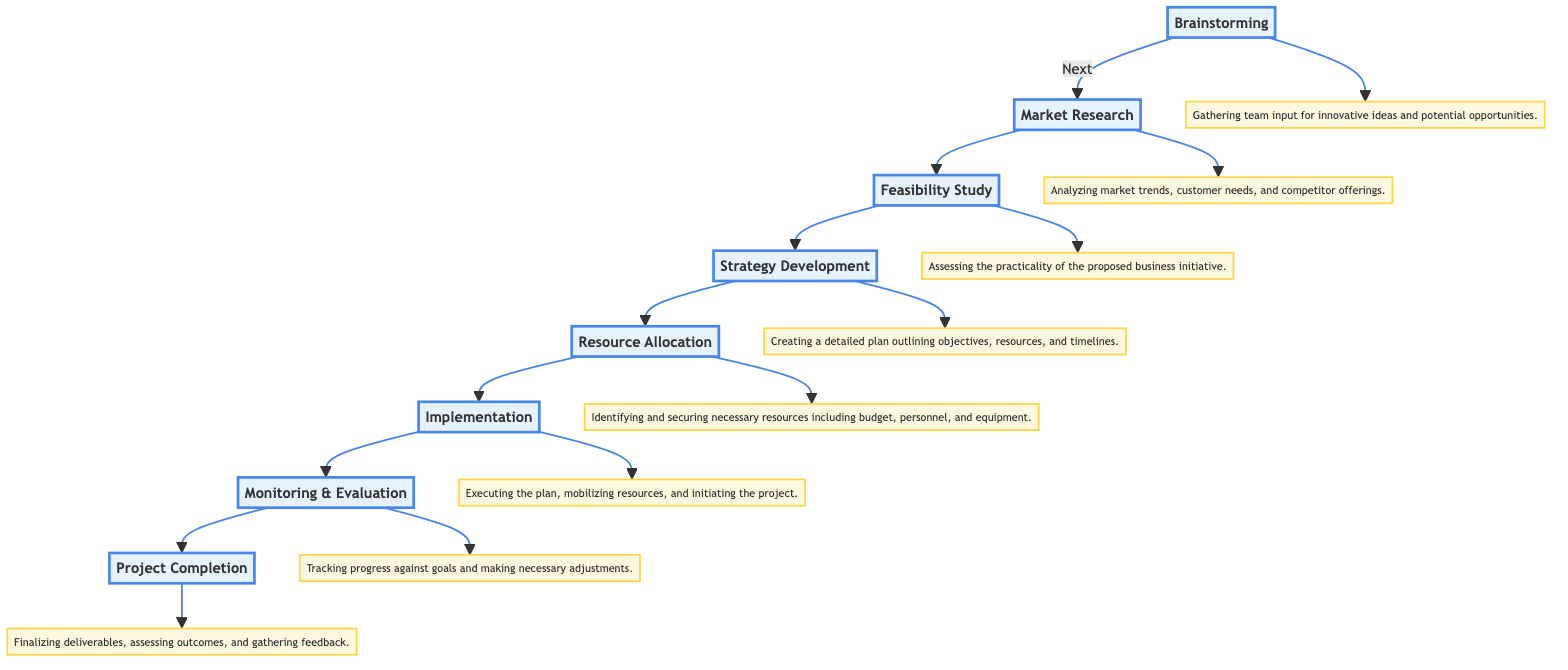What is the first stage of the project planning flow? The first stage depicted in the flow chart is "Brainstorming," which initiates the entire project planning process.
Answer: Brainstorming How many total stages are in the diagram? By counting each distinct stage listed in the flow chart, there are eight stages from "Brainstorming" to "Project Completion."
Answer: Eight What follows the "Market Research" stage? According to the flow, the stage that directly follows "Market Research" is "Feasibility Study," indicating the progression of the project planning process.
Answer: Feasibility Study What is the main focus of the "Implementation" stage? The "Implementation" stage primarily involves executing the plan, mobilizing resources, and initiating the project, as described in the flow chart.
Answer: Executing the plan Which stage involves assessing market trends and customer needs? The stage that entails analyzing market trends and customer insights is "Market Research," highlighting its importance in understanding the market landscape.
Answer: Market Research What stage comes before "Monitoring & Evaluation"? The flow chart shows that "Implementation" occurs prior to "Monitoring & Evaluation," indicating the sequence of these processes within project planning.
Answer: Implementation What is described in the "Strategy Development" stage? The "Strategy Development" stage is characterized by creating a detailed plan that outlines objectives, resources, and timelines needed for the project.
Answer: Creating a detailed plan What do you assess during the "Feasibility Study"? During the "Feasibility Study," one assesses the practicality of the proposed business initiative to determine if it is viable for further development.
Answer: Practicality of the proposed business initiative What happens during "Project Completion"? In the "Project Completion" stage, deliverables are finalized, outcomes are assessed, and feedback is gathered to evaluate the overall success of the project.
Answer: Finalizing deliverables 